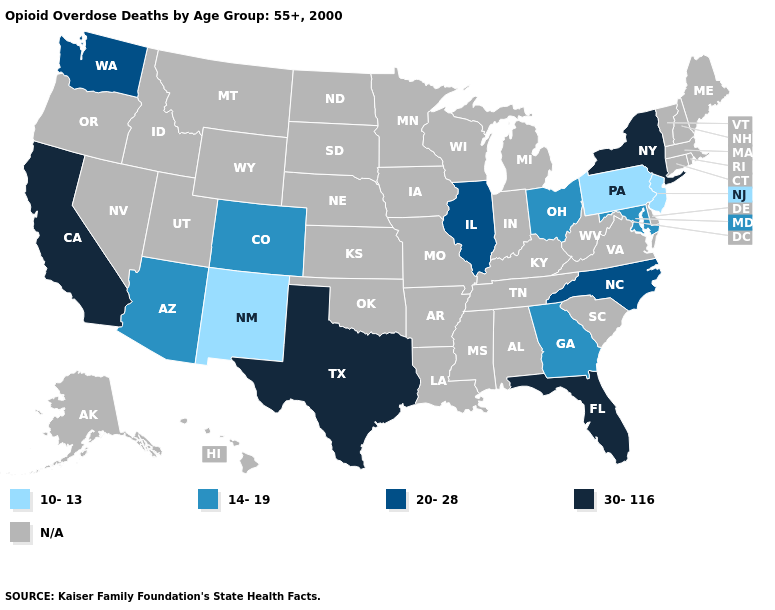What is the value of Rhode Island?
Answer briefly. N/A. Name the states that have a value in the range 14-19?
Keep it brief. Arizona, Colorado, Georgia, Maryland, Ohio. Does the map have missing data?
Concise answer only. Yes. What is the highest value in the USA?
Concise answer only. 30-116. What is the value of Nevada?
Quick response, please. N/A. Name the states that have a value in the range 14-19?
Short answer required. Arizona, Colorado, Georgia, Maryland, Ohio. What is the lowest value in states that border Connecticut?
Keep it brief. 30-116. Is the legend a continuous bar?
Answer briefly. No. What is the highest value in the USA?
Concise answer only. 30-116. What is the highest value in the West ?
Be succinct. 30-116. Is the legend a continuous bar?
Concise answer only. No. What is the value of Delaware?
Give a very brief answer. N/A. Does Washington have the lowest value in the West?
Answer briefly. No. Name the states that have a value in the range 14-19?
Short answer required. Arizona, Colorado, Georgia, Maryland, Ohio. 